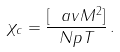<formula> <loc_0><loc_0><loc_500><loc_500>\chi _ { c } = \frac { [ \ a v { M ^ { 2 } } ] } { N p T } \, .</formula> 